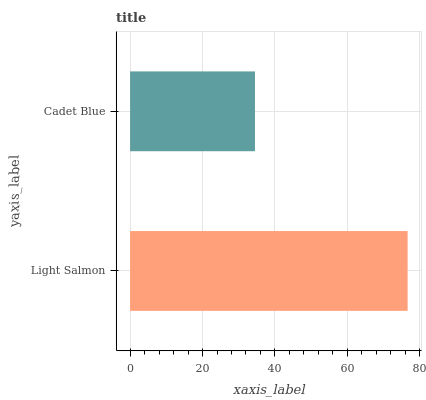Is Cadet Blue the minimum?
Answer yes or no. Yes. Is Light Salmon the maximum?
Answer yes or no. Yes. Is Cadet Blue the maximum?
Answer yes or no. No. Is Light Salmon greater than Cadet Blue?
Answer yes or no. Yes. Is Cadet Blue less than Light Salmon?
Answer yes or no. Yes. Is Cadet Blue greater than Light Salmon?
Answer yes or no. No. Is Light Salmon less than Cadet Blue?
Answer yes or no. No. Is Light Salmon the high median?
Answer yes or no. Yes. Is Cadet Blue the low median?
Answer yes or no. Yes. Is Cadet Blue the high median?
Answer yes or no. No. Is Light Salmon the low median?
Answer yes or no. No. 